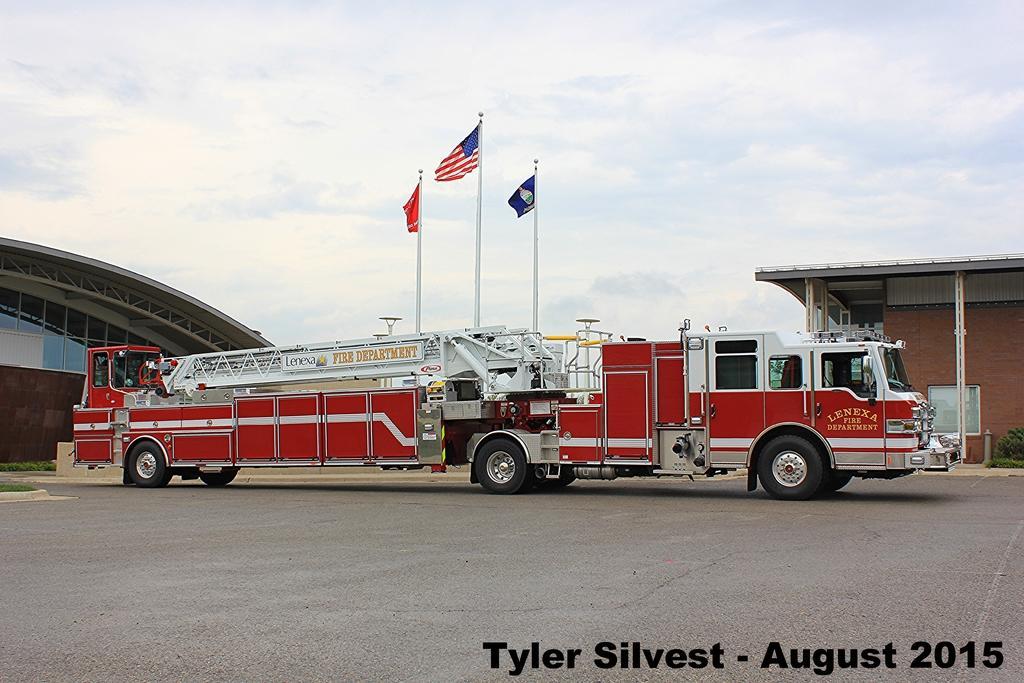Describe this image in one or two sentences. In the image there is a vehicle and there are three flags flying in the sky, on the right side there is a compartment and on the left side there is an architecture in the background, there is some text mentioned on the right side bottom of the image. 